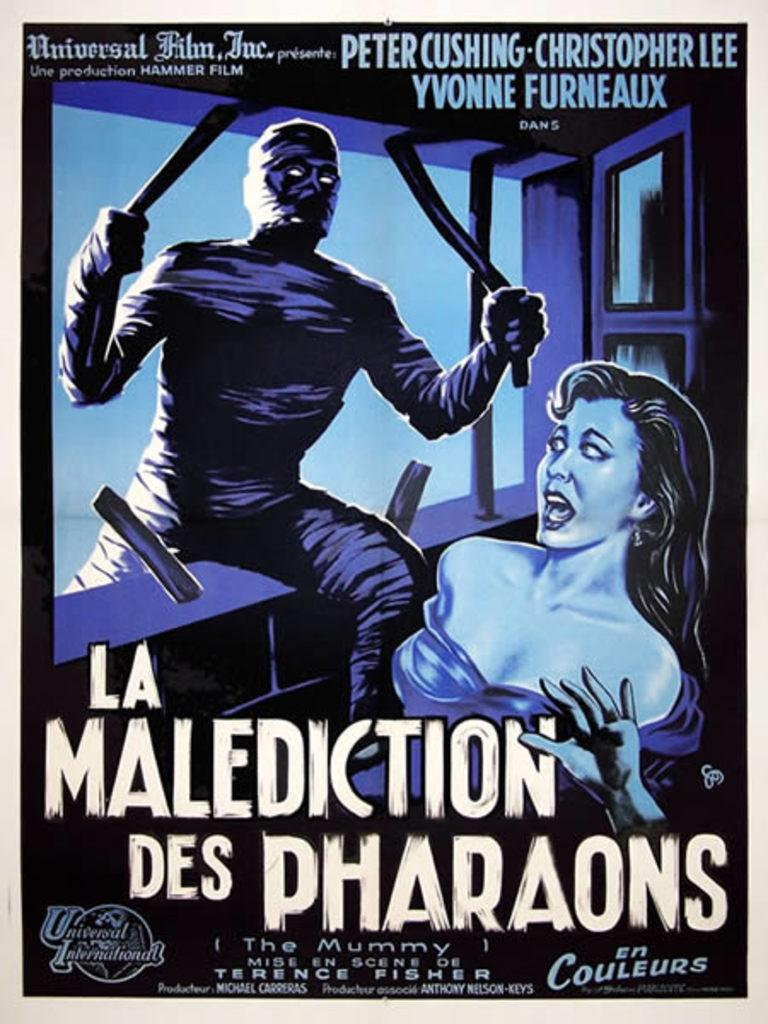Provide a one-sentence caption for the provided image. Poster for a movie titled La Malediction Des Pharaons". 